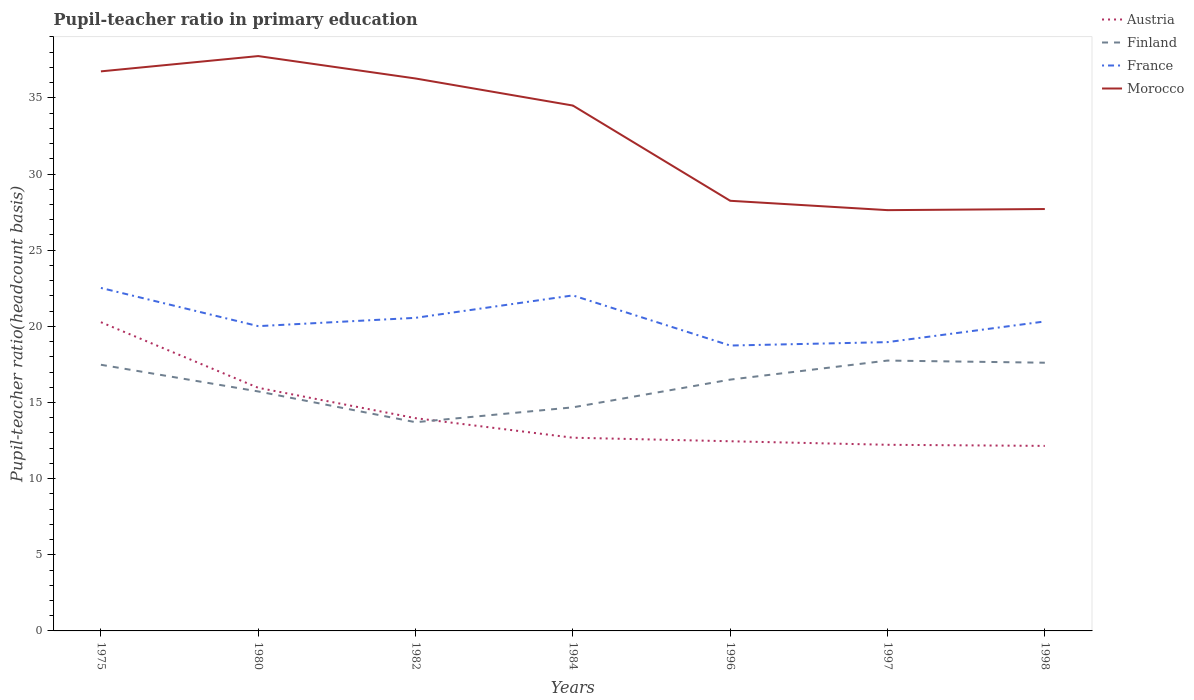How many different coloured lines are there?
Your answer should be very brief. 4. Across all years, what is the maximum pupil-teacher ratio in primary education in Austria?
Give a very brief answer. 12.15. In which year was the pupil-teacher ratio in primary education in Finland maximum?
Offer a terse response. 1982. What is the total pupil-teacher ratio in primary education in France in the graph?
Your answer should be compact. 3.56. What is the difference between the highest and the second highest pupil-teacher ratio in primary education in Austria?
Provide a short and direct response. 8.12. Is the pupil-teacher ratio in primary education in Austria strictly greater than the pupil-teacher ratio in primary education in France over the years?
Give a very brief answer. Yes. How many lines are there?
Make the answer very short. 4. How many years are there in the graph?
Provide a short and direct response. 7. Are the values on the major ticks of Y-axis written in scientific E-notation?
Make the answer very short. No. Does the graph contain any zero values?
Provide a succinct answer. No. What is the title of the graph?
Ensure brevity in your answer.  Pupil-teacher ratio in primary education. What is the label or title of the Y-axis?
Ensure brevity in your answer.  Pupil-teacher ratio(headcount basis). What is the Pupil-teacher ratio(headcount basis) in Austria in 1975?
Provide a short and direct response. 20.27. What is the Pupil-teacher ratio(headcount basis) in Finland in 1975?
Give a very brief answer. 17.48. What is the Pupil-teacher ratio(headcount basis) of France in 1975?
Offer a very short reply. 22.52. What is the Pupil-teacher ratio(headcount basis) in Morocco in 1975?
Provide a succinct answer. 36.74. What is the Pupil-teacher ratio(headcount basis) in Austria in 1980?
Provide a short and direct response. 15.96. What is the Pupil-teacher ratio(headcount basis) in Finland in 1980?
Offer a terse response. 15.72. What is the Pupil-teacher ratio(headcount basis) in France in 1980?
Give a very brief answer. 20.01. What is the Pupil-teacher ratio(headcount basis) of Morocco in 1980?
Ensure brevity in your answer.  37.75. What is the Pupil-teacher ratio(headcount basis) of Austria in 1982?
Ensure brevity in your answer.  13.97. What is the Pupil-teacher ratio(headcount basis) of Finland in 1982?
Your response must be concise. 13.7. What is the Pupil-teacher ratio(headcount basis) of France in 1982?
Offer a terse response. 20.56. What is the Pupil-teacher ratio(headcount basis) in Morocco in 1982?
Offer a very short reply. 36.27. What is the Pupil-teacher ratio(headcount basis) of Austria in 1984?
Keep it short and to the point. 12.69. What is the Pupil-teacher ratio(headcount basis) in Finland in 1984?
Give a very brief answer. 14.68. What is the Pupil-teacher ratio(headcount basis) of France in 1984?
Your answer should be compact. 22.03. What is the Pupil-teacher ratio(headcount basis) of Morocco in 1984?
Your answer should be compact. 34.5. What is the Pupil-teacher ratio(headcount basis) of Austria in 1996?
Make the answer very short. 12.45. What is the Pupil-teacher ratio(headcount basis) of Finland in 1996?
Offer a very short reply. 16.5. What is the Pupil-teacher ratio(headcount basis) in France in 1996?
Your answer should be very brief. 18.74. What is the Pupil-teacher ratio(headcount basis) in Morocco in 1996?
Your answer should be very brief. 28.24. What is the Pupil-teacher ratio(headcount basis) in Austria in 1997?
Offer a terse response. 12.22. What is the Pupil-teacher ratio(headcount basis) in Finland in 1997?
Keep it short and to the point. 17.75. What is the Pupil-teacher ratio(headcount basis) of France in 1997?
Give a very brief answer. 18.96. What is the Pupil-teacher ratio(headcount basis) of Morocco in 1997?
Keep it short and to the point. 27.63. What is the Pupil-teacher ratio(headcount basis) in Austria in 1998?
Provide a succinct answer. 12.15. What is the Pupil-teacher ratio(headcount basis) of Finland in 1998?
Ensure brevity in your answer.  17.61. What is the Pupil-teacher ratio(headcount basis) of France in 1998?
Make the answer very short. 20.32. What is the Pupil-teacher ratio(headcount basis) of Morocco in 1998?
Ensure brevity in your answer.  27.7. Across all years, what is the maximum Pupil-teacher ratio(headcount basis) of Austria?
Make the answer very short. 20.27. Across all years, what is the maximum Pupil-teacher ratio(headcount basis) in Finland?
Your answer should be compact. 17.75. Across all years, what is the maximum Pupil-teacher ratio(headcount basis) of France?
Provide a succinct answer. 22.52. Across all years, what is the maximum Pupil-teacher ratio(headcount basis) of Morocco?
Your answer should be very brief. 37.75. Across all years, what is the minimum Pupil-teacher ratio(headcount basis) of Austria?
Keep it short and to the point. 12.15. Across all years, what is the minimum Pupil-teacher ratio(headcount basis) in Finland?
Keep it short and to the point. 13.7. Across all years, what is the minimum Pupil-teacher ratio(headcount basis) in France?
Your answer should be compact. 18.74. Across all years, what is the minimum Pupil-teacher ratio(headcount basis) of Morocco?
Your answer should be compact. 27.63. What is the total Pupil-teacher ratio(headcount basis) in Austria in the graph?
Provide a succinct answer. 99.71. What is the total Pupil-teacher ratio(headcount basis) of Finland in the graph?
Give a very brief answer. 113.45. What is the total Pupil-teacher ratio(headcount basis) in France in the graph?
Offer a very short reply. 143.14. What is the total Pupil-teacher ratio(headcount basis) of Morocco in the graph?
Offer a very short reply. 228.83. What is the difference between the Pupil-teacher ratio(headcount basis) in Austria in 1975 and that in 1980?
Make the answer very short. 4.31. What is the difference between the Pupil-teacher ratio(headcount basis) in Finland in 1975 and that in 1980?
Offer a terse response. 1.75. What is the difference between the Pupil-teacher ratio(headcount basis) of France in 1975 and that in 1980?
Your answer should be very brief. 2.51. What is the difference between the Pupil-teacher ratio(headcount basis) of Morocco in 1975 and that in 1980?
Offer a very short reply. -1. What is the difference between the Pupil-teacher ratio(headcount basis) of Austria in 1975 and that in 1982?
Provide a succinct answer. 6.3. What is the difference between the Pupil-teacher ratio(headcount basis) of Finland in 1975 and that in 1982?
Offer a very short reply. 3.77. What is the difference between the Pupil-teacher ratio(headcount basis) in France in 1975 and that in 1982?
Your answer should be compact. 1.96. What is the difference between the Pupil-teacher ratio(headcount basis) in Morocco in 1975 and that in 1982?
Ensure brevity in your answer.  0.47. What is the difference between the Pupil-teacher ratio(headcount basis) in Austria in 1975 and that in 1984?
Keep it short and to the point. 7.59. What is the difference between the Pupil-teacher ratio(headcount basis) in Finland in 1975 and that in 1984?
Your response must be concise. 2.8. What is the difference between the Pupil-teacher ratio(headcount basis) in France in 1975 and that in 1984?
Offer a terse response. 0.49. What is the difference between the Pupil-teacher ratio(headcount basis) of Morocco in 1975 and that in 1984?
Ensure brevity in your answer.  2.24. What is the difference between the Pupil-teacher ratio(headcount basis) in Austria in 1975 and that in 1996?
Your answer should be compact. 7.82. What is the difference between the Pupil-teacher ratio(headcount basis) of Finland in 1975 and that in 1996?
Ensure brevity in your answer.  0.98. What is the difference between the Pupil-teacher ratio(headcount basis) of France in 1975 and that in 1996?
Keep it short and to the point. 3.78. What is the difference between the Pupil-teacher ratio(headcount basis) in Morocco in 1975 and that in 1996?
Offer a very short reply. 8.5. What is the difference between the Pupil-teacher ratio(headcount basis) of Austria in 1975 and that in 1997?
Your answer should be compact. 8.05. What is the difference between the Pupil-teacher ratio(headcount basis) in Finland in 1975 and that in 1997?
Make the answer very short. -0.28. What is the difference between the Pupil-teacher ratio(headcount basis) in France in 1975 and that in 1997?
Offer a very short reply. 3.56. What is the difference between the Pupil-teacher ratio(headcount basis) of Morocco in 1975 and that in 1997?
Make the answer very short. 9.11. What is the difference between the Pupil-teacher ratio(headcount basis) of Austria in 1975 and that in 1998?
Your response must be concise. 8.12. What is the difference between the Pupil-teacher ratio(headcount basis) in Finland in 1975 and that in 1998?
Give a very brief answer. -0.13. What is the difference between the Pupil-teacher ratio(headcount basis) of France in 1975 and that in 1998?
Your answer should be compact. 2.2. What is the difference between the Pupil-teacher ratio(headcount basis) of Morocco in 1975 and that in 1998?
Provide a short and direct response. 9.04. What is the difference between the Pupil-teacher ratio(headcount basis) of Austria in 1980 and that in 1982?
Your response must be concise. 1.99. What is the difference between the Pupil-teacher ratio(headcount basis) in Finland in 1980 and that in 1982?
Offer a very short reply. 2.02. What is the difference between the Pupil-teacher ratio(headcount basis) of France in 1980 and that in 1982?
Give a very brief answer. -0.55. What is the difference between the Pupil-teacher ratio(headcount basis) of Morocco in 1980 and that in 1982?
Keep it short and to the point. 1.47. What is the difference between the Pupil-teacher ratio(headcount basis) in Austria in 1980 and that in 1984?
Keep it short and to the point. 3.28. What is the difference between the Pupil-teacher ratio(headcount basis) of Finland in 1980 and that in 1984?
Give a very brief answer. 1.04. What is the difference between the Pupil-teacher ratio(headcount basis) in France in 1980 and that in 1984?
Offer a very short reply. -2.02. What is the difference between the Pupil-teacher ratio(headcount basis) in Morocco in 1980 and that in 1984?
Make the answer very short. 3.25. What is the difference between the Pupil-teacher ratio(headcount basis) of Austria in 1980 and that in 1996?
Your answer should be very brief. 3.51. What is the difference between the Pupil-teacher ratio(headcount basis) of Finland in 1980 and that in 1996?
Ensure brevity in your answer.  -0.78. What is the difference between the Pupil-teacher ratio(headcount basis) in France in 1980 and that in 1996?
Keep it short and to the point. 1.27. What is the difference between the Pupil-teacher ratio(headcount basis) in Morocco in 1980 and that in 1996?
Your answer should be compact. 9.5. What is the difference between the Pupil-teacher ratio(headcount basis) in Austria in 1980 and that in 1997?
Ensure brevity in your answer.  3.74. What is the difference between the Pupil-teacher ratio(headcount basis) of Finland in 1980 and that in 1997?
Make the answer very short. -2.03. What is the difference between the Pupil-teacher ratio(headcount basis) of France in 1980 and that in 1997?
Your answer should be very brief. 1.05. What is the difference between the Pupil-teacher ratio(headcount basis) in Morocco in 1980 and that in 1997?
Your response must be concise. 10.12. What is the difference between the Pupil-teacher ratio(headcount basis) in Austria in 1980 and that in 1998?
Keep it short and to the point. 3.81. What is the difference between the Pupil-teacher ratio(headcount basis) in Finland in 1980 and that in 1998?
Ensure brevity in your answer.  -1.89. What is the difference between the Pupil-teacher ratio(headcount basis) in France in 1980 and that in 1998?
Keep it short and to the point. -0.31. What is the difference between the Pupil-teacher ratio(headcount basis) in Morocco in 1980 and that in 1998?
Your response must be concise. 10.04. What is the difference between the Pupil-teacher ratio(headcount basis) in Austria in 1982 and that in 1984?
Your answer should be very brief. 1.28. What is the difference between the Pupil-teacher ratio(headcount basis) in Finland in 1982 and that in 1984?
Provide a short and direct response. -0.98. What is the difference between the Pupil-teacher ratio(headcount basis) in France in 1982 and that in 1984?
Your answer should be compact. -1.47. What is the difference between the Pupil-teacher ratio(headcount basis) in Morocco in 1982 and that in 1984?
Provide a short and direct response. 1.78. What is the difference between the Pupil-teacher ratio(headcount basis) in Austria in 1982 and that in 1996?
Give a very brief answer. 1.51. What is the difference between the Pupil-teacher ratio(headcount basis) of Finland in 1982 and that in 1996?
Ensure brevity in your answer.  -2.8. What is the difference between the Pupil-teacher ratio(headcount basis) in France in 1982 and that in 1996?
Your answer should be very brief. 1.82. What is the difference between the Pupil-teacher ratio(headcount basis) of Morocco in 1982 and that in 1996?
Your answer should be very brief. 8.03. What is the difference between the Pupil-teacher ratio(headcount basis) in Austria in 1982 and that in 1997?
Your response must be concise. 1.75. What is the difference between the Pupil-teacher ratio(headcount basis) in Finland in 1982 and that in 1997?
Provide a succinct answer. -4.05. What is the difference between the Pupil-teacher ratio(headcount basis) in France in 1982 and that in 1997?
Ensure brevity in your answer.  1.6. What is the difference between the Pupil-teacher ratio(headcount basis) in Morocco in 1982 and that in 1997?
Your response must be concise. 8.64. What is the difference between the Pupil-teacher ratio(headcount basis) in Austria in 1982 and that in 1998?
Offer a terse response. 1.82. What is the difference between the Pupil-teacher ratio(headcount basis) of Finland in 1982 and that in 1998?
Offer a terse response. -3.91. What is the difference between the Pupil-teacher ratio(headcount basis) of France in 1982 and that in 1998?
Offer a terse response. 0.24. What is the difference between the Pupil-teacher ratio(headcount basis) in Morocco in 1982 and that in 1998?
Provide a succinct answer. 8.57. What is the difference between the Pupil-teacher ratio(headcount basis) in Austria in 1984 and that in 1996?
Give a very brief answer. 0.23. What is the difference between the Pupil-teacher ratio(headcount basis) in Finland in 1984 and that in 1996?
Provide a short and direct response. -1.82. What is the difference between the Pupil-teacher ratio(headcount basis) of France in 1984 and that in 1996?
Offer a very short reply. 3.29. What is the difference between the Pupil-teacher ratio(headcount basis) in Morocco in 1984 and that in 1996?
Your response must be concise. 6.25. What is the difference between the Pupil-teacher ratio(headcount basis) in Austria in 1984 and that in 1997?
Your answer should be very brief. 0.47. What is the difference between the Pupil-teacher ratio(headcount basis) in Finland in 1984 and that in 1997?
Make the answer very short. -3.07. What is the difference between the Pupil-teacher ratio(headcount basis) of France in 1984 and that in 1997?
Ensure brevity in your answer.  3.07. What is the difference between the Pupil-teacher ratio(headcount basis) in Morocco in 1984 and that in 1997?
Keep it short and to the point. 6.87. What is the difference between the Pupil-teacher ratio(headcount basis) in Austria in 1984 and that in 1998?
Ensure brevity in your answer.  0.54. What is the difference between the Pupil-teacher ratio(headcount basis) of Finland in 1984 and that in 1998?
Provide a succinct answer. -2.93. What is the difference between the Pupil-teacher ratio(headcount basis) of France in 1984 and that in 1998?
Your answer should be compact. 1.71. What is the difference between the Pupil-teacher ratio(headcount basis) of Morocco in 1984 and that in 1998?
Make the answer very short. 6.79. What is the difference between the Pupil-teacher ratio(headcount basis) of Austria in 1996 and that in 1997?
Provide a short and direct response. 0.23. What is the difference between the Pupil-teacher ratio(headcount basis) in Finland in 1996 and that in 1997?
Your response must be concise. -1.25. What is the difference between the Pupil-teacher ratio(headcount basis) of France in 1996 and that in 1997?
Your response must be concise. -0.22. What is the difference between the Pupil-teacher ratio(headcount basis) of Morocco in 1996 and that in 1997?
Provide a short and direct response. 0.61. What is the difference between the Pupil-teacher ratio(headcount basis) of Austria in 1996 and that in 1998?
Give a very brief answer. 0.3. What is the difference between the Pupil-teacher ratio(headcount basis) of Finland in 1996 and that in 1998?
Keep it short and to the point. -1.11. What is the difference between the Pupil-teacher ratio(headcount basis) in France in 1996 and that in 1998?
Your response must be concise. -1.58. What is the difference between the Pupil-teacher ratio(headcount basis) in Morocco in 1996 and that in 1998?
Make the answer very short. 0.54. What is the difference between the Pupil-teacher ratio(headcount basis) of Austria in 1997 and that in 1998?
Make the answer very short. 0.07. What is the difference between the Pupil-teacher ratio(headcount basis) of Finland in 1997 and that in 1998?
Give a very brief answer. 0.14. What is the difference between the Pupil-teacher ratio(headcount basis) of France in 1997 and that in 1998?
Your answer should be compact. -1.36. What is the difference between the Pupil-teacher ratio(headcount basis) in Morocco in 1997 and that in 1998?
Your answer should be compact. -0.07. What is the difference between the Pupil-teacher ratio(headcount basis) of Austria in 1975 and the Pupil-teacher ratio(headcount basis) of Finland in 1980?
Your answer should be compact. 4.55. What is the difference between the Pupil-teacher ratio(headcount basis) of Austria in 1975 and the Pupil-teacher ratio(headcount basis) of France in 1980?
Ensure brevity in your answer.  0.26. What is the difference between the Pupil-teacher ratio(headcount basis) of Austria in 1975 and the Pupil-teacher ratio(headcount basis) of Morocco in 1980?
Your answer should be compact. -17.47. What is the difference between the Pupil-teacher ratio(headcount basis) of Finland in 1975 and the Pupil-teacher ratio(headcount basis) of France in 1980?
Keep it short and to the point. -2.54. What is the difference between the Pupil-teacher ratio(headcount basis) of Finland in 1975 and the Pupil-teacher ratio(headcount basis) of Morocco in 1980?
Keep it short and to the point. -20.27. What is the difference between the Pupil-teacher ratio(headcount basis) in France in 1975 and the Pupil-teacher ratio(headcount basis) in Morocco in 1980?
Offer a terse response. -15.22. What is the difference between the Pupil-teacher ratio(headcount basis) of Austria in 1975 and the Pupil-teacher ratio(headcount basis) of Finland in 1982?
Offer a terse response. 6.57. What is the difference between the Pupil-teacher ratio(headcount basis) of Austria in 1975 and the Pupil-teacher ratio(headcount basis) of France in 1982?
Ensure brevity in your answer.  -0.29. What is the difference between the Pupil-teacher ratio(headcount basis) in Austria in 1975 and the Pupil-teacher ratio(headcount basis) in Morocco in 1982?
Your answer should be very brief. -16. What is the difference between the Pupil-teacher ratio(headcount basis) in Finland in 1975 and the Pupil-teacher ratio(headcount basis) in France in 1982?
Provide a succinct answer. -3.08. What is the difference between the Pupil-teacher ratio(headcount basis) in Finland in 1975 and the Pupil-teacher ratio(headcount basis) in Morocco in 1982?
Offer a very short reply. -18.8. What is the difference between the Pupil-teacher ratio(headcount basis) of France in 1975 and the Pupil-teacher ratio(headcount basis) of Morocco in 1982?
Offer a terse response. -13.75. What is the difference between the Pupil-teacher ratio(headcount basis) in Austria in 1975 and the Pupil-teacher ratio(headcount basis) in Finland in 1984?
Your answer should be compact. 5.59. What is the difference between the Pupil-teacher ratio(headcount basis) of Austria in 1975 and the Pupil-teacher ratio(headcount basis) of France in 1984?
Your answer should be very brief. -1.76. What is the difference between the Pupil-teacher ratio(headcount basis) of Austria in 1975 and the Pupil-teacher ratio(headcount basis) of Morocco in 1984?
Give a very brief answer. -14.22. What is the difference between the Pupil-teacher ratio(headcount basis) of Finland in 1975 and the Pupil-teacher ratio(headcount basis) of France in 1984?
Keep it short and to the point. -4.55. What is the difference between the Pupil-teacher ratio(headcount basis) in Finland in 1975 and the Pupil-teacher ratio(headcount basis) in Morocco in 1984?
Offer a very short reply. -17.02. What is the difference between the Pupil-teacher ratio(headcount basis) in France in 1975 and the Pupil-teacher ratio(headcount basis) in Morocco in 1984?
Your answer should be compact. -11.98. What is the difference between the Pupil-teacher ratio(headcount basis) of Austria in 1975 and the Pupil-teacher ratio(headcount basis) of Finland in 1996?
Provide a succinct answer. 3.77. What is the difference between the Pupil-teacher ratio(headcount basis) in Austria in 1975 and the Pupil-teacher ratio(headcount basis) in France in 1996?
Your answer should be very brief. 1.53. What is the difference between the Pupil-teacher ratio(headcount basis) of Austria in 1975 and the Pupil-teacher ratio(headcount basis) of Morocco in 1996?
Your response must be concise. -7.97. What is the difference between the Pupil-teacher ratio(headcount basis) of Finland in 1975 and the Pupil-teacher ratio(headcount basis) of France in 1996?
Provide a short and direct response. -1.26. What is the difference between the Pupil-teacher ratio(headcount basis) of Finland in 1975 and the Pupil-teacher ratio(headcount basis) of Morocco in 1996?
Keep it short and to the point. -10.77. What is the difference between the Pupil-teacher ratio(headcount basis) of France in 1975 and the Pupil-teacher ratio(headcount basis) of Morocco in 1996?
Ensure brevity in your answer.  -5.72. What is the difference between the Pupil-teacher ratio(headcount basis) in Austria in 1975 and the Pupil-teacher ratio(headcount basis) in Finland in 1997?
Ensure brevity in your answer.  2.52. What is the difference between the Pupil-teacher ratio(headcount basis) of Austria in 1975 and the Pupil-teacher ratio(headcount basis) of France in 1997?
Your answer should be very brief. 1.31. What is the difference between the Pupil-teacher ratio(headcount basis) of Austria in 1975 and the Pupil-teacher ratio(headcount basis) of Morocco in 1997?
Ensure brevity in your answer.  -7.36. What is the difference between the Pupil-teacher ratio(headcount basis) of Finland in 1975 and the Pupil-teacher ratio(headcount basis) of France in 1997?
Provide a succinct answer. -1.49. What is the difference between the Pupil-teacher ratio(headcount basis) of Finland in 1975 and the Pupil-teacher ratio(headcount basis) of Morocco in 1997?
Keep it short and to the point. -10.15. What is the difference between the Pupil-teacher ratio(headcount basis) in France in 1975 and the Pupil-teacher ratio(headcount basis) in Morocco in 1997?
Offer a terse response. -5.11. What is the difference between the Pupil-teacher ratio(headcount basis) of Austria in 1975 and the Pupil-teacher ratio(headcount basis) of Finland in 1998?
Your answer should be compact. 2.66. What is the difference between the Pupil-teacher ratio(headcount basis) in Austria in 1975 and the Pupil-teacher ratio(headcount basis) in France in 1998?
Ensure brevity in your answer.  -0.05. What is the difference between the Pupil-teacher ratio(headcount basis) of Austria in 1975 and the Pupil-teacher ratio(headcount basis) of Morocco in 1998?
Give a very brief answer. -7.43. What is the difference between the Pupil-teacher ratio(headcount basis) in Finland in 1975 and the Pupil-teacher ratio(headcount basis) in France in 1998?
Offer a terse response. -2.84. What is the difference between the Pupil-teacher ratio(headcount basis) of Finland in 1975 and the Pupil-teacher ratio(headcount basis) of Morocco in 1998?
Keep it short and to the point. -10.22. What is the difference between the Pupil-teacher ratio(headcount basis) of France in 1975 and the Pupil-teacher ratio(headcount basis) of Morocco in 1998?
Make the answer very short. -5.18. What is the difference between the Pupil-teacher ratio(headcount basis) in Austria in 1980 and the Pupil-teacher ratio(headcount basis) in Finland in 1982?
Make the answer very short. 2.26. What is the difference between the Pupil-teacher ratio(headcount basis) in Austria in 1980 and the Pupil-teacher ratio(headcount basis) in France in 1982?
Your response must be concise. -4.59. What is the difference between the Pupil-teacher ratio(headcount basis) in Austria in 1980 and the Pupil-teacher ratio(headcount basis) in Morocco in 1982?
Provide a succinct answer. -20.31. What is the difference between the Pupil-teacher ratio(headcount basis) in Finland in 1980 and the Pupil-teacher ratio(headcount basis) in France in 1982?
Provide a succinct answer. -4.83. What is the difference between the Pupil-teacher ratio(headcount basis) in Finland in 1980 and the Pupil-teacher ratio(headcount basis) in Morocco in 1982?
Keep it short and to the point. -20.55. What is the difference between the Pupil-teacher ratio(headcount basis) in France in 1980 and the Pupil-teacher ratio(headcount basis) in Morocco in 1982?
Keep it short and to the point. -16.26. What is the difference between the Pupil-teacher ratio(headcount basis) in Austria in 1980 and the Pupil-teacher ratio(headcount basis) in Finland in 1984?
Keep it short and to the point. 1.28. What is the difference between the Pupil-teacher ratio(headcount basis) in Austria in 1980 and the Pupil-teacher ratio(headcount basis) in France in 1984?
Ensure brevity in your answer.  -6.07. What is the difference between the Pupil-teacher ratio(headcount basis) in Austria in 1980 and the Pupil-teacher ratio(headcount basis) in Morocco in 1984?
Offer a terse response. -18.53. What is the difference between the Pupil-teacher ratio(headcount basis) of Finland in 1980 and the Pupil-teacher ratio(headcount basis) of France in 1984?
Your answer should be compact. -6.31. What is the difference between the Pupil-teacher ratio(headcount basis) of Finland in 1980 and the Pupil-teacher ratio(headcount basis) of Morocco in 1984?
Your answer should be compact. -18.77. What is the difference between the Pupil-teacher ratio(headcount basis) of France in 1980 and the Pupil-teacher ratio(headcount basis) of Morocco in 1984?
Provide a short and direct response. -14.48. What is the difference between the Pupil-teacher ratio(headcount basis) in Austria in 1980 and the Pupil-teacher ratio(headcount basis) in Finland in 1996?
Make the answer very short. -0.54. What is the difference between the Pupil-teacher ratio(headcount basis) in Austria in 1980 and the Pupil-teacher ratio(headcount basis) in France in 1996?
Give a very brief answer. -2.77. What is the difference between the Pupil-teacher ratio(headcount basis) in Austria in 1980 and the Pupil-teacher ratio(headcount basis) in Morocco in 1996?
Ensure brevity in your answer.  -12.28. What is the difference between the Pupil-teacher ratio(headcount basis) of Finland in 1980 and the Pupil-teacher ratio(headcount basis) of France in 1996?
Provide a short and direct response. -3.01. What is the difference between the Pupil-teacher ratio(headcount basis) in Finland in 1980 and the Pupil-teacher ratio(headcount basis) in Morocco in 1996?
Your answer should be very brief. -12.52. What is the difference between the Pupil-teacher ratio(headcount basis) in France in 1980 and the Pupil-teacher ratio(headcount basis) in Morocco in 1996?
Your answer should be very brief. -8.23. What is the difference between the Pupil-teacher ratio(headcount basis) in Austria in 1980 and the Pupil-teacher ratio(headcount basis) in Finland in 1997?
Provide a succinct answer. -1.79. What is the difference between the Pupil-teacher ratio(headcount basis) in Austria in 1980 and the Pupil-teacher ratio(headcount basis) in France in 1997?
Keep it short and to the point. -3. What is the difference between the Pupil-teacher ratio(headcount basis) in Austria in 1980 and the Pupil-teacher ratio(headcount basis) in Morocco in 1997?
Give a very brief answer. -11.67. What is the difference between the Pupil-teacher ratio(headcount basis) in Finland in 1980 and the Pupil-teacher ratio(headcount basis) in France in 1997?
Your answer should be very brief. -3.24. What is the difference between the Pupil-teacher ratio(headcount basis) in Finland in 1980 and the Pupil-teacher ratio(headcount basis) in Morocco in 1997?
Your response must be concise. -11.9. What is the difference between the Pupil-teacher ratio(headcount basis) of France in 1980 and the Pupil-teacher ratio(headcount basis) of Morocco in 1997?
Offer a terse response. -7.62. What is the difference between the Pupil-teacher ratio(headcount basis) in Austria in 1980 and the Pupil-teacher ratio(headcount basis) in Finland in 1998?
Your answer should be compact. -1.65. What is the difference between the Pupil-teacher ratio(headcount basis) of Austria in 1980 and the Pupil-teacher ratio(headcount basis) of France in 1998?
Make the answer very short. -4.36. What is the difference between the Pupil-teacher ratio(headcount basis) of Austria in 1980 and the Pupil-teacher ratio(headcount basis) of Morocco in 1998?
Offer a very short reply. -11.74. What is the difference between the Pupil-teacher ratio(headcount basis) of Finland in 1980 and the Pupil-teacher ratio(headcount basis) of France in 1998?
Keep it short and to the point. -4.59. What is the difference between the Pupil-teacher ratio(headcount basis) in Finland in 1980 and the Pupil-teacher ratio(headcount basis) in Morocco in 1998?
Give a very brief answer. -11.98. What is the difference between the Pupil-teacher ratio(headcount basis) in France in 1980 and the Pupil-teacher ratio(headcount basis) in Morocco in 1998?
Provide a succinct answer. -7.69. What is the difference between the Pupil-teacher ratio(headcount basis) in Austria in 1982 and the Pupil-teacher ratio(headcount basis) in Finland in 1984?
Offer a terse response. -0.71. What is the difference between the Pupil-teacher ratio(headcount basis) of Austria in 1982 and the Pupil-teacher ratio(headcount basis) of France in 1984?
Your answer should be very brief. -8.06. What is the difference between the Pupil-teacher ratio(headcount basis) in Austria in 1982 and the Pupil-teacher ratio(headcount basis) in Morocco in 1984?
Your answer should be compact. -20.53. What is the difference between the Pupil-teacher ratio(headcount basis) in Finland in 1982 and the Pupil-teacher ratio(headcount basis) in France in 1984?
Provide a succinct answer. -8.33. What is the difference between the Pupil-teacher ratio(headcount basis) in Finland in 1982 and the Pupil-teacher ratio(headcount basis) in Morocco in 1984?
Keep it short and to the point. -20.79. What is the difference between the Pupil-teacher ratio(headcount basis) of France in 1982 and the Pupil-teacher ratio(headcount basis) of Morocco in 1984?
Offer a terse response. -13.94. What is the difference between the Pupil-teacher ratio(headcount basis) in Austria in 1982 and the Pupil-teacher ratio(headcount basis) in Finland in 1996?
Provide a succinct answer. -2.53. What is the difference between the Pupil-teacher ratio(headcount basis) of Austria in 1982 and the Pupil-teacher ratio(headcount basis) of France in 1996?
Keep it short and to the point. -4.77. What is the difference between the Pupil-teacher ratio(headcount basis) in Austria in 1982 and the Pupil-teacher ratio(headcount basis) in Morocco in 1996?
Offer a terse response. -14.27. What is the difference between the Pupil-teacher ratio(headcount basis) in Finland in 1982 and the Pupil-teacher ratio(headcount basis) in France in 1996?
Provide a short and direct response. -5.03. What is the difference between the Pupil-teacher ratio(headcount basis) in Finland in 1982 and the Pupil-teacher ratio(headcount basis) in Morocco in 1996?
Make the answer very short. -14.54. What is the difference between the Pupil-teacher ratio(headcount basis) of France in 1982 and the Pupil-teacher ratio(headcount basis) of Morocco in 1996?
Your response must be concise. -7.69. What is the difference between the Pupil-teacher ratio(headcount basis) of Austria in 1982 and the Pupil-teacher ratio(headcount basis) of Finland in 1997?
Offer a very short reply. -3.78. What is the difference between the Pupil-teacher ratio(headcount basis) of Austria in 1982 and the Pupil-teacher ratio(headcount basis) of France in 1997?
Keep it short and to the point. -4.99. What is the difference between the Pupil-teacher ratio(headcount basis) of Austria in 1982 and the Pupil-teacher ratio(headcount basis) of Morocco in 1997?
Your answer should be very brief. -13.66. What is the difference between the Pupil-teacher ratio(headcount basis) of Finland in 1982 and the Pupil-teacher ratio(headcount basis) of France in 1997?
Provide a succinct answer. -5.26. What is the difference between the Pupil-teacher ratio(headcount basis) in Finland in 1982 and the Pupil-teacher ratio(headcount basis) in Morocco in 1997?
Your answer should be very brief. -13.92. What is the difference between the Pupil-teacher ratio(headcount basis) of France in 1982 and the Pupil-teacher ratio(headcount basis) of Morocco in 1997?
Your response must be concise. -7.07. What is the difference between the Pupil-teacher ratio(headcount basis) in Austria in 1982 and the Pupil-teacher ratio(headcount basis) in Finland in 1998?
Offer a very short reply. -3.64. What is the difference between the Pupil-teacher ratio(headcount basis) of Austria in 1982 and the Pupil-teacher ratio(headcount basis) of France in 1998?
Ensure brevity in your answer.  -6.35. What is the difference between the Pupil-teacher ratio(headcount basis) in Austria in 1982 and the Pupil-teacher ratio(headcount basis) in Morocco in 1998?
Your answer should be compact. -13.73. What is the difference between the Pupil-teacher ratio(headcount basis) of Finland in 1982 and the Pupil-teacher ratio(headcount basis) of France in 1998?
Provide a short and direct response. -6.61. What is the difference between the Pupil-teacher ratio(headcount basis) in Finland in 1982 and the Pupil-teacher ratio(headcount basis) in Morocco in 1998?
Your answer should be compact. -14. What is the difference between the Pupil-teacher ratio(headcount basis) of France in 1982 and the Pupil-teacher ratio(headcount basis) of Morocco in 1998?
Give a very brief answer. -7.14. What is the difference between the Pupil-teacher ratio(headcount basis) in Austria in 1984 and the Pupil-teacher ratio(headcount basis) in Finland in 1996?
Provide a succinct answer. -3.81. What is the difference between the Pupil-teacher ratio(headcount basis) of Austria in 1984 and the Pupil-teacher ratio(headcount basis) of France in 1996?
Keep it short and to the point. -6.05. What is the difference between the Pupil-teacher ratio(headcount basis) in Austria in 1984 and the Pupil-teacher ratio(headcount basis) in Morocco in 1996?
Give a very brief answer. -15.56. What is the difference between the Pupil-teacher ratio(headcount basis) of Finland in 1984 and the Pupil-teacher ratio(headcount basis) of France in 1996?
Provide a succinct answer. -4.06. What is the difference between the Pupil-teacher ratio(headcount basis) in Finland in 1984 and the Pupil-teacher ratio(headcount basis) in Morocco in 1996?
Provide a succinct answer. -13.56. What is the difference between the Pupil-teacher ratio(headcount basis) of France in 1984 and the Pupil-teacher ratio(headcount basis) of Morocco in 1996?
Your answer should be very brief. -6.21. What is the difference between the Pupil-teacher ratio(headcount basis) in Austria in 1984 and the Pupil-teacher ratio(headcount basis) in Finland in 1997?
Keep it short and to the point. -5.07. What is the difference between the Pupil-teacher ratio(headcount basis) of Austria in 1984 and the Pupil-teacher ratio(headcount basis) of France in 1997?
Ensure brevity in your answer.  -6.28. What is the difference between the Pupil-teacher ratio(headcount basis) of Austria in 1984 and the Pupil-teacher ratio(headcount basis) of Morocco in 1997?
Make the answer very short. -14.94. What is the difference between the Pupil-teacher ratio(headcount basis) in Finland in 1984 and the Pupil-teacher ratio(headcount basis) in France in 1997?
Make the answer very short. -4.28. What is the difference between the Pupil-teacher ratio(headcount basis) of Finland in 1984 and the Pupil-teacher ratio(headcount basis) of Morocco in 1997?
Your answer should be very brief. -12.95. What is the difference between the Pupil-teacher ratio(headcount basis) in France in 1984 and the Pupil-teacher ratio(headcount basis) in Morocco in 1997?
Provide a succinct answer. -5.6. What is the difference between the Pupil-teacher ratio(headcount basis) in Austria in 1984 and the Pupil-teacher ratio(headcount basis) in Finland in 1998?
Your response must be concise. -4.92. What is the difference between the Pupil-teacher ratio(headcount basis) in Austria in 1984 and the Pupil-teacher ratio(headcount basis) in France in 1998?
Ensure brevity in your answer.  -7.63. What is the difference between the Pupil-teacher ratio(headcount basis) in Austria in 1984 and the Pupil-teacher ratio(headcount basis) in Morocco in 1998?
Provide a succinct answer. -15.01. What is the difference between the Pupil-teacher ratio(headcount basis) of Finland in 1984 and the Pupil-teacher ratio(headcount basis) of France in 1998?
Your answer should be compact. -5.64. What is the difference between the Pupil-teacher ratio(headcount basis) of Finland in 1984 and the Pupil-teacher ratio(headcount basis) of Morocco in 1998?
Make the answer very short. -13.02. What is the difference between the Pupil-teacher ratio(headcount basis) in France in 1984 and the Pupil-teacher ratio(headcount basis) in Morocco in 1998?
Provide a succinct answer. -5.67. What is the difference between the Pupil-teacher ratio(headcount basis) of Austria in 1996 and the Pupil-teacher ratio(headcount basis) of Finland in 1997?
Provide a succinct answer. -5.3. What is the difference between the Pupil-teacher ratio(headcount basis) of Austria in 1996 and the Pupil-teacher ratio(headcount basis) of France in 1997?
Your response must be concise. -6.51. What is the difference between the Pupil-teacher ratio(headcount basis) in Austria in 1996 and the Pupil-teacher ratio(headcount basis) in Morocco in 1997?
Give a very brief answer. -15.18. What is the difference between the Pupil-teacher ratio(headcount basis) of Finland in 1996 and the Pupil-teacher ratio(headcount basis) of France in 1997?
Keep it short and to the point. -2.46. What is the difference between the Pupil-teacher ratio(headcount basis) in Finland in 1996 and the Pupil-teacher ratio(headcount basis) in Morocco in 1997?
Provide a short and direct response. -11.13. What is the difference between the Pupil-teacher ratio(headcount basis) in France in 1996 and the Pupil-teacher ratio(headcount basis) in Morocco in 1997?
Keep it short and to the point. -8.89. What is the difference between the Pupil-teacher ratio(headcount basis) of Austria in 1996 and the Pupil-teacher ratio(headcount basis) of Finland in 1998?
Keep it short and to the point. -5.16. What is the difference between the Pupil-teacher ratio(headcount basis) of Austria in 1996 and the Pupil-teacher ratio(headcount basis) of France in 1998?
Ensure brevity in your answer.  -7.87. What is the difference between the Pupil-teacher ratio(headcount basis) in Austria in 1996 and the Pupil-teacher ratio(headcount basis) in Morocco in 1998?
Keep it short and to the point. -15.25. What is the difference between the Pupil-teacher ratio(headcount basis) of Finland in 1996 and the Pupil-teacher ratio(headcount basis) of France in 1998?
Make the answer very short. -3.82. What is the difference between the Pupil-teacher ratio(headcount basis) of Finland in 1996 and the Pupil-teacher ratio(headcount basis) of Morocco in 1998?
Make the answer very short. -11.2. What is the difference between the Pupil-teacher ratio(headcount basis) of France in 1996 and the Pupil-teacher ratio(headcount basis) of Morocco in 1998?
Give a very brief answer. -8.96. What is the difference between the Pupil-teacher ratio(headcount basis) of Austria in 1997 and the Pupil-teacher ratio(headcount basis) of Finland in 1998?
Your answer should be very brief. -5.39. What is the difference between the Pupil-teacher ratio(headcount basis) in Austria in 1997 and the Pupil-teacher ratio(headcount basis) in France in 1998?
Your response must be concise. -8.1. What is the difference between the Pupil-teacher ratio(headcount basis) in Austria in 1997 and the Pupil-teacher ratio(headcount basis) in Morocco in 1998?
Provide a short and direct response. -15.48. What is the difference between the Pupil-teacher ratio(headcount basis) in Finland in 1997 and the Pupil-teacher ratio(headcount basis) in France in 1998?
Your response must be concise. -2.57. What is the difference between the Pupil-teacher ratio(headcount basis) in Finland in 1997 and the Pupil-teacher ratio(headcount basis) in Morocco in 1998?
Keep it short and to the point. -9.95. What is the difference between the Pupil-teacher ratio(headcount basis) of France in 1997 and the Pupil-teacher ratio(headcount basis) of Morocco in 1998?
Your response must be concise. -8.74. What is the average Pupil-teacher ratio(headcount basis) in Austria per year?
Ensure brevity in your answer.  14.24. What is the average Pupil-teacher ratio(headcount basis) in Finland per year?
Provide a succinct answer. 16.21. What is the average Pupil-teacher ratio(headcount basis) in France per year?
Make the answer very short. 20.45. What is the average Pupil-teacher ratio(headcount basis) of Morocco per year?
Provide a succinct answer. 32.69. In the year 1975, what is the difference between the Pupil-teacher ratio(headcount basis) of Austria and Pupil-teacher ratio(headcount basis) of Finland?
Ensure brevity in your answer.  2.8. In the year 1975, what is the difference between the Pupil-teacher ratio(headcount basis) of Austria and Pupil-teacher ratio(headcount basis) of France?
Provide a succinct answer. -2.25. In the year 1975, what is the difference between the Pupil-teacher ratio(headcount basis) of Austria and Pupil-teacher ratio(headcount basis) of Morocco?
Your answer should be very brief. -16.47. In the year 1975, what is the difference between the Pupil-teacher ratio(headcount basis) of Finland and Pupil-teacher ratio(headcount basis) of France?
Provide a short and direct response. -5.04. In the year 1975, what is the difference between the Pupil-teacher ratio(headcount basis) in Finland and Pupil-teacher ratio(headcount basis) in Morocco?
Your response must be concise. -19.26. In the year 1975, what is the difference between the Pupil-teacher ratio(headcount basis) of France and Pupil-teacher ratio(headcount basis) of Morocco?
Your response must be concise. -14.22. In the year 1980, what is the difference between the Pupil-teacher ratio(headcount basis) of Austria and Pupil-teacher ratio(headcount basis) of Finland?
Ensure brevity in your answer.  0.24. In the year 1980, what is the difference between the Pupil-teacher ratio(headcount basis) of Austria and Pupil-teacher ratio(headcount basis) of France?
Offer a terse response. -4.05. In the year 1980, what is the difference between the Pupil-teacher ratio(headcount basis) in Austria and Pupil-teacher ratio(headcount basis) in Morocco?
Provide a short and direct response. -21.78. In the year 1980, what is the difference between the Pupil-teacher ratio(headcount basis) in Finland and Pupil-teacher ratio(headcount basis) in France?
Make the answer very short. -4.29. In the year 1980, what is the difference between the Pupil-teacher ratio(headcount basis) of Finland and Pupil-teacher ratio(headcount basis) of Morocco?
Your answer should be compact. -22.02. In the year 1980, what is the difference between the Pupil-teacher ratio(headcount basis) in France and Pupil-teacher ratio(headcount basis) in Morocco?
Ensure brevity in your answer.  -17.73. In the year 1982, what is the difference between the Pupil-teacher ratio(headcount basis) of Austria and Pupil-teacher ratio(headcount basis) of Finland?
Keep it short and to the point. 0.26. In the year 1982, what is the difference between the Pupil-teacher ratio(headcount basis) of Austria and Pupil-teacher ratio(headcount basis) of France?
Your response must be concise. -6.59. In the year 1982, what is the difference between the Pupil-teacher ratio(headcount basis) of Austria and Pupil-teacher ratio(headcount basis) of Morocco?
Your answer should be compact. -22.3. In the year 1982, what is the difference between the Pupil-teacher ratio(headcount basis) of Finland and Pupil-teacher ratio(headcount basis) of France?
Ensure brevity in your answer.  -6.85. In the year 1982, what is the difference between the Pupil-teacher ratio(headcount basis) in Finland and Pupil-teacher ratio(headcount basis) in Morocco?
Your response must be concise. -22.57. In the year 1982, what is the difference between the Pupil-teacher ratio(headcount basis) of France and Pupil-teacher ratio(headcount basis) of Morocco?
Provide a short and direct response. -15.72. In the year 1984, what is the difference between the Pupil-teacher ratio(headcount basis) in Austria and Pupil-teacher ratio(headcount basis) in Finland?
Provide a succinct answer. -1.99. In the year 1984, what is the difference between the Pupil-teacher ratio(headcount basis) of Austria and Pupil-teacher ratio(headcount basis) of France?
Your response must be concise. -9.34. In the year 1984, what is the difference between the Pupil-teacher ratio(headcount basis) of Austria and Pupil-teacher ratio(headcount basis) of Morocco?
Make the answer very short. -21.81. In the year 1984, what is the difference between the Pupil-teacher ratio(headcount basis) in Finland and Pupil-teacher ratio(headcount basis) in France?
Offer a terse response. -7.35. In the year 1984, what is the difference between the Pupil-teacher ratio(headcount basis) of Finland and Pupil-teacher ratio(headcount basis) of Morocco?
Provide a succinct answer. -19.82. In the year 1984, what is the difference between the Pupil-teacher ratio(headcount basis) of France and Pupil-teacher ratio(headcount basis) of Morocco?
Ensure brevity in your answer.  -12.47. In the year 1996, what is the difference between the Pupil-teacher ratio(headcount basis) in Austria and Pupil-teacher ratio(headcount basis) in Finland?
Your response must be concise. -4.05. In the year 1996, what is the difference between the Pupil-teacher ratio(headcount basis) in Austria and Pupil-teacher ratio(headcount basis) in France?
Ensure brevity in your answer.  -6.28. In the year 1996, what is the difference between the Pupil-teacher ratio(headcount basis) in Austria and Pupil-teacher ratio(headcount basis) in Morocco?
Your answer should be very brief. -15.79. In the year 1996, what is the difference between the Pupil-teacher ratio(headcount basis) in Finland and Pupil-teacher ratio(headcount basis) in France?
Keep it short and to the point. -2.24. In the year 1996, what is the difference between the Pupil-teacher ratio(headcount basis) in Finland and Pupil-teacher ratio(headcount basis) in Morocco?
Offer a terse response. -11.74. In the year 1996, what is the difference between the Pupil-teacher ratio(headcount basis) in France and Pupil-teacher ratio(headcount basis) in Morocco?
Keep it short and to the point. -9.5. In the year 1997, what is the difference between the Pupil-teacher ratio(headcount basis) of Austria and Pupil-teacher ratio(headcount basis) of Finland?
Your response must be concise. -5.53. In the year 1997, what is the difference between the Pupil-teacher ratio(headcount basis) of Austria and Pupil-teacher ratio(headcount basis) of France?
Provide a succinct answer. -6.74. In the year 1997, what is the difference between the Pupil-teacher ratio(headcount basis) in Austria and Pupil-teacher ratio(headcount basis) in Morocco?
Make the answer very short. -15.41. In the year 1997, what is the difference between the Pupil-teacher ratio(headcount basis) of Finland and Pupil-teacher ratio(headcount basis) of France?
Your response must be concise. -1.21. In the year 1997, what is the difference between the Pupil-teacher ratio(headcount basis) in Finland and Pupil-teacher ratio(headcount basis) in Morocco?
Your response must be concise. -9.88. In the year 1997, what is the difference between the Pupil-teacher ratio(headcount basis) in France and Pupil-teacher ratio(headcount basis) in Morocco?
Your answer should be compact. -8.67. In the year 1998, what is the difference between the Pupil-teacher ratio(headcount basis) in Austria and Pupil-teacher ratio(headcount basis) in Finland?
Give a very brief answer. -5.46. In the year 1998, what is the difference between the Pupil-teacher ratio(headcount basis) of Austria and Pupil-teacher ratio(headcount basis) of France?
Provide a succinct answer. -8.17. In the year 1998, what is the difference between the Pupil-teacher ratio(headcount basis) of Austria and Pupil-teacher ratio(headcount basis) of Morocco?
Provide a short and direct response. -15.55. In the year 1998, what is the difference between the Pupil-teacher ratio(headcount basis) of Finland and Pupil-teacher ratio(headcount basis) of France?
Provide a succinct answer. -2.71. In the year 1998, what is the difference between the Pupil-teacher ratio(headcount basis) of Finland and Pupil-teacher ratio(headcount basis) of Morocco?
Provide a succinct answer. -10.09. In the year 1998, what is the difference between the Pupil-teacher ratio(headcount basis) of France and Pupil-teacher ratio(headcount basis) of Morocco?
Your answer should be very brief. -7.38. What is the ratio of the Pupil-teacher ratio(headcount basis) of Austria in 1975 to that in 1980?
Your answer should be very brief. 1.27. What is the ratio of the Pupil-teacher ratio(headcount basis) of Finland in 1975 to that in 1980?
Your response must be concise. 1.11. What is the ratio of the Pupil-teacher ratio(headcount basis) in France in 1975 to that in 1980?
Your answer should be very brief. 1.13. What is the ratio of the Pupil-teacher ratio(headcount basis) in Morocco in 1975 to that in 1980?
Give a very brief answer. 0.97. What is the ratio of the Pupil-teacher ratio(headcount basis) of Austria in 1975 to that in 1982?
Provide a short and direct response. 1.45. What is the ratio of the Pupil-teacher ratio(headcount basis) of Finland in 1975 to that in 1982?
Offer a very short reply. 1.28. What is the ratio of the Pupil-teacher ratio(headcount basis) of France in 1975 to that in 1982?
Offer a very short reply. 1.1. What is the ratio of the Pupil-teacher ratio(headcount basis) of Morocco in 1975 to that in 1982?
Ensure brevity in your answer.  1.01. What is the ratio of the Pupil-teacher ratio(headcount basis) in Austria in 1975 to that in 1984?
Provide a short and direct response. 1.6. What is the ratio of the Pupil-teacher ratio(headcount basis) in Finland in 1975 to that in 1984?
Your answer should be compact. 1.19. What is the ratio of the Pupil-teacher ratio(headcount basis) in France in 1975 to that in 1984?
Keep it short and to the point. 1.02. What is the ratio of the Pupil-teacher ratio(headcount basis) of Morocco in 1975 to that in 1984?
Your answer should be compact. 1.07. What is the ratio of the Pupil-teacher ratio(headcount basis) of Austria in 1975 to that in 1996?
Your answer should be compact. 1.63. What is the ratio of the Pupil-teacher ratio(headcount basis) of Finland in 1975 to that in 1996?
Keep it short and to the point. 1.06. What is the ratio of the Pupil-teacher ratio(headcount basis) in France in 1975 to that in 1996?
Give a very brief answer. 1.2. What is the ratio of the Pupil-teacher ratio(headcount basis) of Morocco in 1975 to that in 1996?
Provide a succinct answer. 1.3. What is the ratio of the Pupil-teacher ratio(headcount basis) in Austria in 1975 to that in 1997?
Your response must be concise. 1.66. What is the ratio of the Pupil-teacher ratio(headcount basis) in Finland in 1975 to that in 1997?
Ensure brevity in your answer.  0.98. What is the ratio of the Pupil-teacher ratio(headcount basis) in France in 1975 to that in 1997?
Provide a succinct answer. 1.19. What is the ratio of the Pupil-teacher ratio(headcount basis) of Morocco in 1975 to that in 1997?
Offer a very short reply. 1.33. What is the ratio of the Pupil-teacher ratio(headcount basis) of Austria in 1975 to that in 1998?
Give a very brief answer. 1.67. What is the ratio of the Pupil-teacher ratio(headcount basis) of France in 1975 to that in 1998?
Make the answer very short. 1.11. What is the ratio of the Pupil-teacher ratio(headcount basis) in Morocco in 1975 to that in 1998?
Make the answer very short. 1.33. What is the ratio of the Pupil-teacher ratio(headcount basis) in Austria in 1980 to that in 1982?
Keep it short and to the point. 1.14. What is the ratio of the Pupil-teacher ratio(headcount basis) of Finland in 1980 to that in 1982?
Provide a succinct answer. 1.15. What is the ratio of the Pupil-teacher ratio(headcount basis) of France in 1980 to that in 1982?
Provide a short and direct response. 0.97. What is the ratio of the Pupil-teacher ratio(headcount basis) in Morocco in 1980 to that in 1982?
Provide a succinct answer. 1.04. What is the ratio of the Pupil-teacher ratio(headcount basis) in Austria in 1980 to that in 1984?
Make the answer very short. 1.26. What is the ratio of the Pupil-teacher ratio(headcount basis) in Finland in 1980 to that in 1984?
Offer a terse response. 1.07. What is the ratio of the Pupil-teacher ratio(headcount basis) of France in 1980 to that in 1984?
Your response must be concise. 0.91. What is the ratio of the Pupil-teacher ratio(headcount basis) in Morocco in 1980 to that in 1984?
Offer a very short reply. 1.09. What is the ratio of the Pupil-teacher ratio(headcount basis) of Austria in 1980 to that in 1996?
Give a very brief answer. 1.28. What is the ratio of the Pupil-teacher ratio(headcount basis) of Finland in 1980 to that in 1996?
Give a very brief answer. 0.95. What is the ratio of the Pupil-teacher ratio(headcount basis) in France in 1980 to that in 1996?
Make the answer very short. 1.07. What is the ratio of the Pupil-teacher ratio(headcount basis) of Morocco in 1980 to that in 1996?
Provide a short and direct response. 1.34. What is the ratio of the Pupil-teacher ratio(headcount basis) in Austria in 1980 to that in 1997?
Offer a terse response. 1.31. What is the ratio of the Pupil-teacher ratio(headcount basis) in Finland in 1980 to that in 1997?
Make the answer very short. 0.89. What is the ratio of the Pupil-teacher ratio(headcount basis) of France in 1980 to that in 1997?
Provide a short and direct response. 1.06. What is the ratio of the Pupil-teacher ratio(headcount basis) of Morocco in 1980 to that in 1997?
Make the answer very short. 1.37. What is the ratio of the Pupil-teacher ratio(headcount basis) of Austria in 1980 to that in 1998?
Provide a succinct answer. 1.31. What is the ratio of the Pupil-teacher ratio(headcount basis) in Finland in 1980 to that in 1998?
Make the answer very short. 0.89. What is the ratio of the Pupil-teacher ratio(headcount basis) of France in 1980 to that in 1998?
Ensure brevity in your answer.  0.98. What is the ratio of the Pupil-teacher ratio(headcount basis) of Morocco in 1980 to that in 1998?
Make the answer very short. 1.36. What is the ratio of the Pupil-teacher ratio(headcount basis) in Austria in 1982 to that in 1984?
Ensure brevity in your answer.  1.1. What is the ratio of the Pupil-teacher ratio(headcount basis) in Finland in 1982 to that in 1984?
Offer a very short reply. 0.93. What is the ratio of the Pupil-teacher ratio(headcount basis) in France in 1982 to that in 1984?
Offer a very short reply. 0.93. What is the ratio of the Pupil-teacher ratio(headcount basis) of Morocco in 1982 to that in 1984?
Your response must be concise. 1.05. What is the ratio of the Pupil-teacher ratio(headcount basis) in Austria in 1982 to that in 1996?
Your answer should be compact. 1.12. What is the ratio of the Pupil-teacher ratio(headcount basis) in Finland in 1982 to that in 1996?
Provide a succinct answer. 0.83. What is the ratio of the Pupil-teacher ratio(headcount basis) of France in 1982 to that in 1996?
Offer a terse response. 1.1. What is the ratio of the Pupil-teacher ratio(headcount basis) of Morocco in 1982 to that in 1996?
Provide a short and direct response. 1.28. What is the ratio of the Pupil-teacher ratio(headcount basis) in Austria in 1982 to that in 1997?
Make the answer very short. 1.14. What is the ratio of the Pupil-teacher ratio(headcount basis) in Finland in 1982 to that in 1997?
Your answer should be compact. 0.77. What is the ratio of the Pupil-teacher ratio(headcount basis) in France in 1982 to that in 1997?
Give a very brief answer. 1.08. What is the ratio of the Pupil-teacher ratio(headcount basis) of Morocco in 1982 to that in 1997?
Keep it short and to the point. 1.31. What is the ratio of the Pupil-teacher ratio(headcount basis) of Austria in 1982 to that in 1998?
Offer a very short reply. 1.15. What is the ratio of the Pupil-teacher ratio(headcount basis) of Finland in 1982 to that in 1998?
Offer a terse response. 0.78. What is the ratio of the Pupil-teacher ratio(headcount basis) of France in 1982 to that in 1998?
Provide a succinct answer. 1.01. What is the ratio of the Pupil-teacher ratio(headcount basis) in Morocco in 1982 to that in 1998?
Offer a terse response. 1.31. What is the ratio of the Pupil-teacher ratio(headcount basis) in Austria in 1984 to that in 1996?
Offer a very short reply. 1.02. What is the ratio of the Pupil-teacher ratio(headcount basis) in Finland in 1984 to that in 1996?
Provide a short and direct response. 0.89. What is the ratio of the Pupil-teacher ratio(headcount basis) of France in 1984 to that in 1996?
Offer a terse response. 1.18. What is the ratio of the Pupil-teacher ratio(headcount basis) in Morocco in 1984 to that in 1996?
Your answer should be compact. 1.22. What is the ratio of the Pupil-teacher ratio(headcount basis) of Austria in 1984 to that in 1997?
Your answer should be very brief. 1.04. What is the ratio of the Pupil-teacher ratio(headcount basis) of Finland in 1984 to that in 1997?
Give a very brief answer. 0.83. What is the ratio of the Pupil-teacher ratio(headcount basis) of France in 1984 to that in 1997?
Offer a very short reply. 1.16. What is the ratio of the Pupil-teacher ratio(headcount basis) of Morocco in 1984 to that in 1997?
Give a very brief answer. 1.25. What is the ratio of the Pupil-teacher ratio(headcount basis) of Austria in 1984 to that in 1998?
Ensure brevity in your answer.  1.04. What is the ratio of the Pupil-teacher ratio(headcount basis) in Finland in 1984 to that in 1998?
Your answer should be compact. 0.83. What is the ratio of the Pupil-teacher ratio(headcount basis) in France in 1984 to that in 1998?
Keep it short and to the point. 1.08. What is the ratio of the Pupil-teacher ratio(headcount basis) in Morocco in 1984 to that in 1998?
Your answer should be very brief. 1.25. What is the ratio of the Pupil-teacher ratio(headcount basis) in Austria in 1996 to that in 1997?
Your response must be concise. 1.02. What is the ratio of the Pupil-teacher ratio(headcount basis) in Finland in 1996 to that in 1997?
Offer a very short reply. 0.93. What is the ratio of the Pupil-teacher ratio(headcount basis) in France in 1996 to that in 1997?
Offer a terse response. 0.99. What is the ratio of the Pupil-teacher ratio(headcount basis) of Morocco in 1996 to that in 1997?
Your response must be concise. 1.02. What is the ratio of the Pupil-teacher ratio(headcount basis) in Austria in 1996 to that in 1998?
Your response must be concise. 1.03. What is the ratio of the Pupil-teacher ratio(headcount basis) of Finland in 1996 to that in 1998?
Keep it short and to the point. 0.94. What is the ratio of the Pupil-teacher ratio(headcount basis) in France in 1996 to that in 1998?
Ensure brevity in your answer.  0.92. What is the ratio of the Pupil-teacher ratio(headcount basis) in Morocco in 1996 to that in 1998?
Provide a succinct answer. 1.02. What is the ratio of the Pupil-teacher ratio(headcount basis) in Finland in 1997 to that in 1998?
Your answer should be very brief. 1.01. What is the ratio of the Pupil-teacher ratio(headcount basis) of France in 1997 to that in 1998?
Offer a terse response. 0.93. What is the ratio of the Pupil-teacher ratio(headcount basis) in Morocco in 1997 to that in 1998?
Offer a very short reply. 1. What is the difference between the highest and the second highest Pupil-teacher ratio(headcount basis) in Austria?
Keep it short and to the point. 4.31. What is the difference between the highest and the second highest Pupil-teacher ratio(headcount basis) of Finland?
Make the answer very short. 0.14. What is the difference between the highest and the second highest Pupil-teacher ratio(headcount basis) in France?
Offer a terse response. 0.49. What is the difference between the highest and the lowest Pupil-teacher ratio(headcount basis) in Austria?
Your answer should be very brief. 8.12. What is the difference between the highest and the lowest Pupil-teacher ratio(headcount basis) in Finland?
Your response must be concise. 4.05. What is the difference between the highest and the lowest Pupil-teacher ratio(headcount basis) of France?
Give a very brief answer. 3.78. What is the difference between the highest and the lowest Pupil-teacher ratio(headcount basis) in Morocco?
Ensure brevity in your answer.  10.12. 